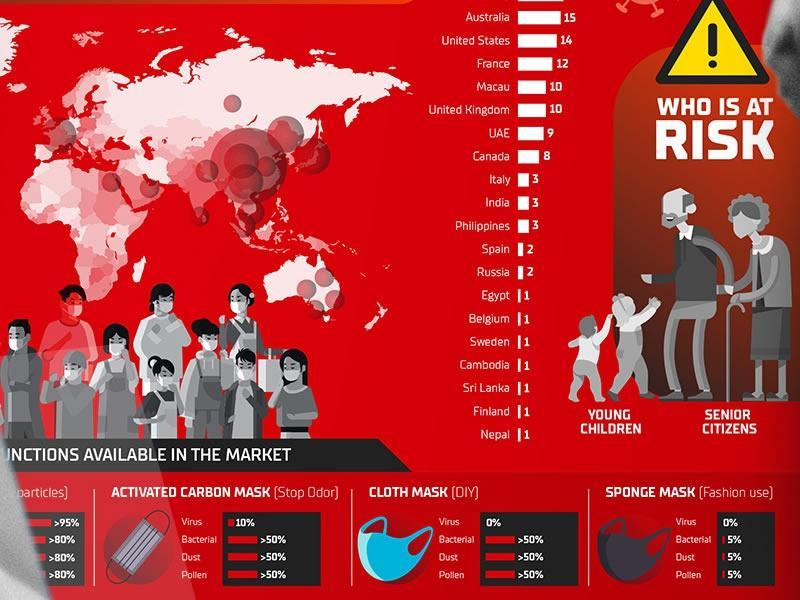Sponge mask gives 5% protection against what
Answer the question with a short phrase. Bacterial, Dust, Pollen Who is at risk Young children, Senior Citizens Against what does the cloth mask doesnt protect Virus What provides >50% protection to Bacterial, Dust and Pollen Activated Carbon Mask, Cloth Mask What is the total count of Srilanka and Nepal 2 